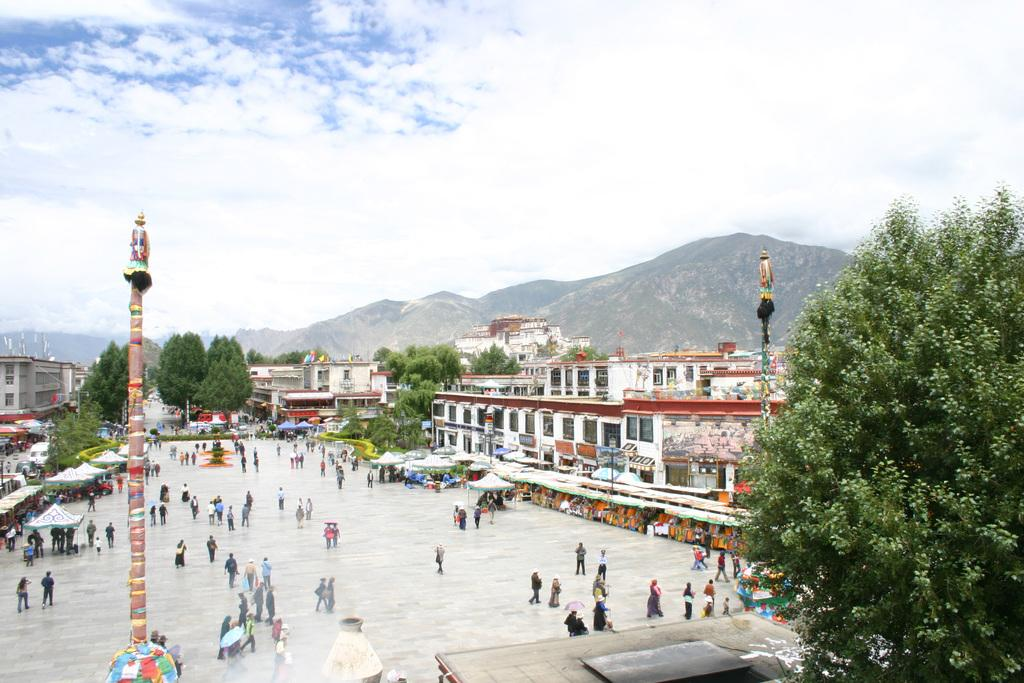How many people can be seen in the image? There are people in the image, but the exact number cannot be determined from the provided facts. What type of structures are present in the image? There are sheds and buildings in the image. What type of natural elements can be seen in the image? There are trees and hills. What type of man-made structures are present in the image? There are poles. What is visible in the sky in the image? The sky is visible in the image, and clouds are present. What type of song is being sung by the trees in the image? There is no indication in the image that the trees are singing a song. 